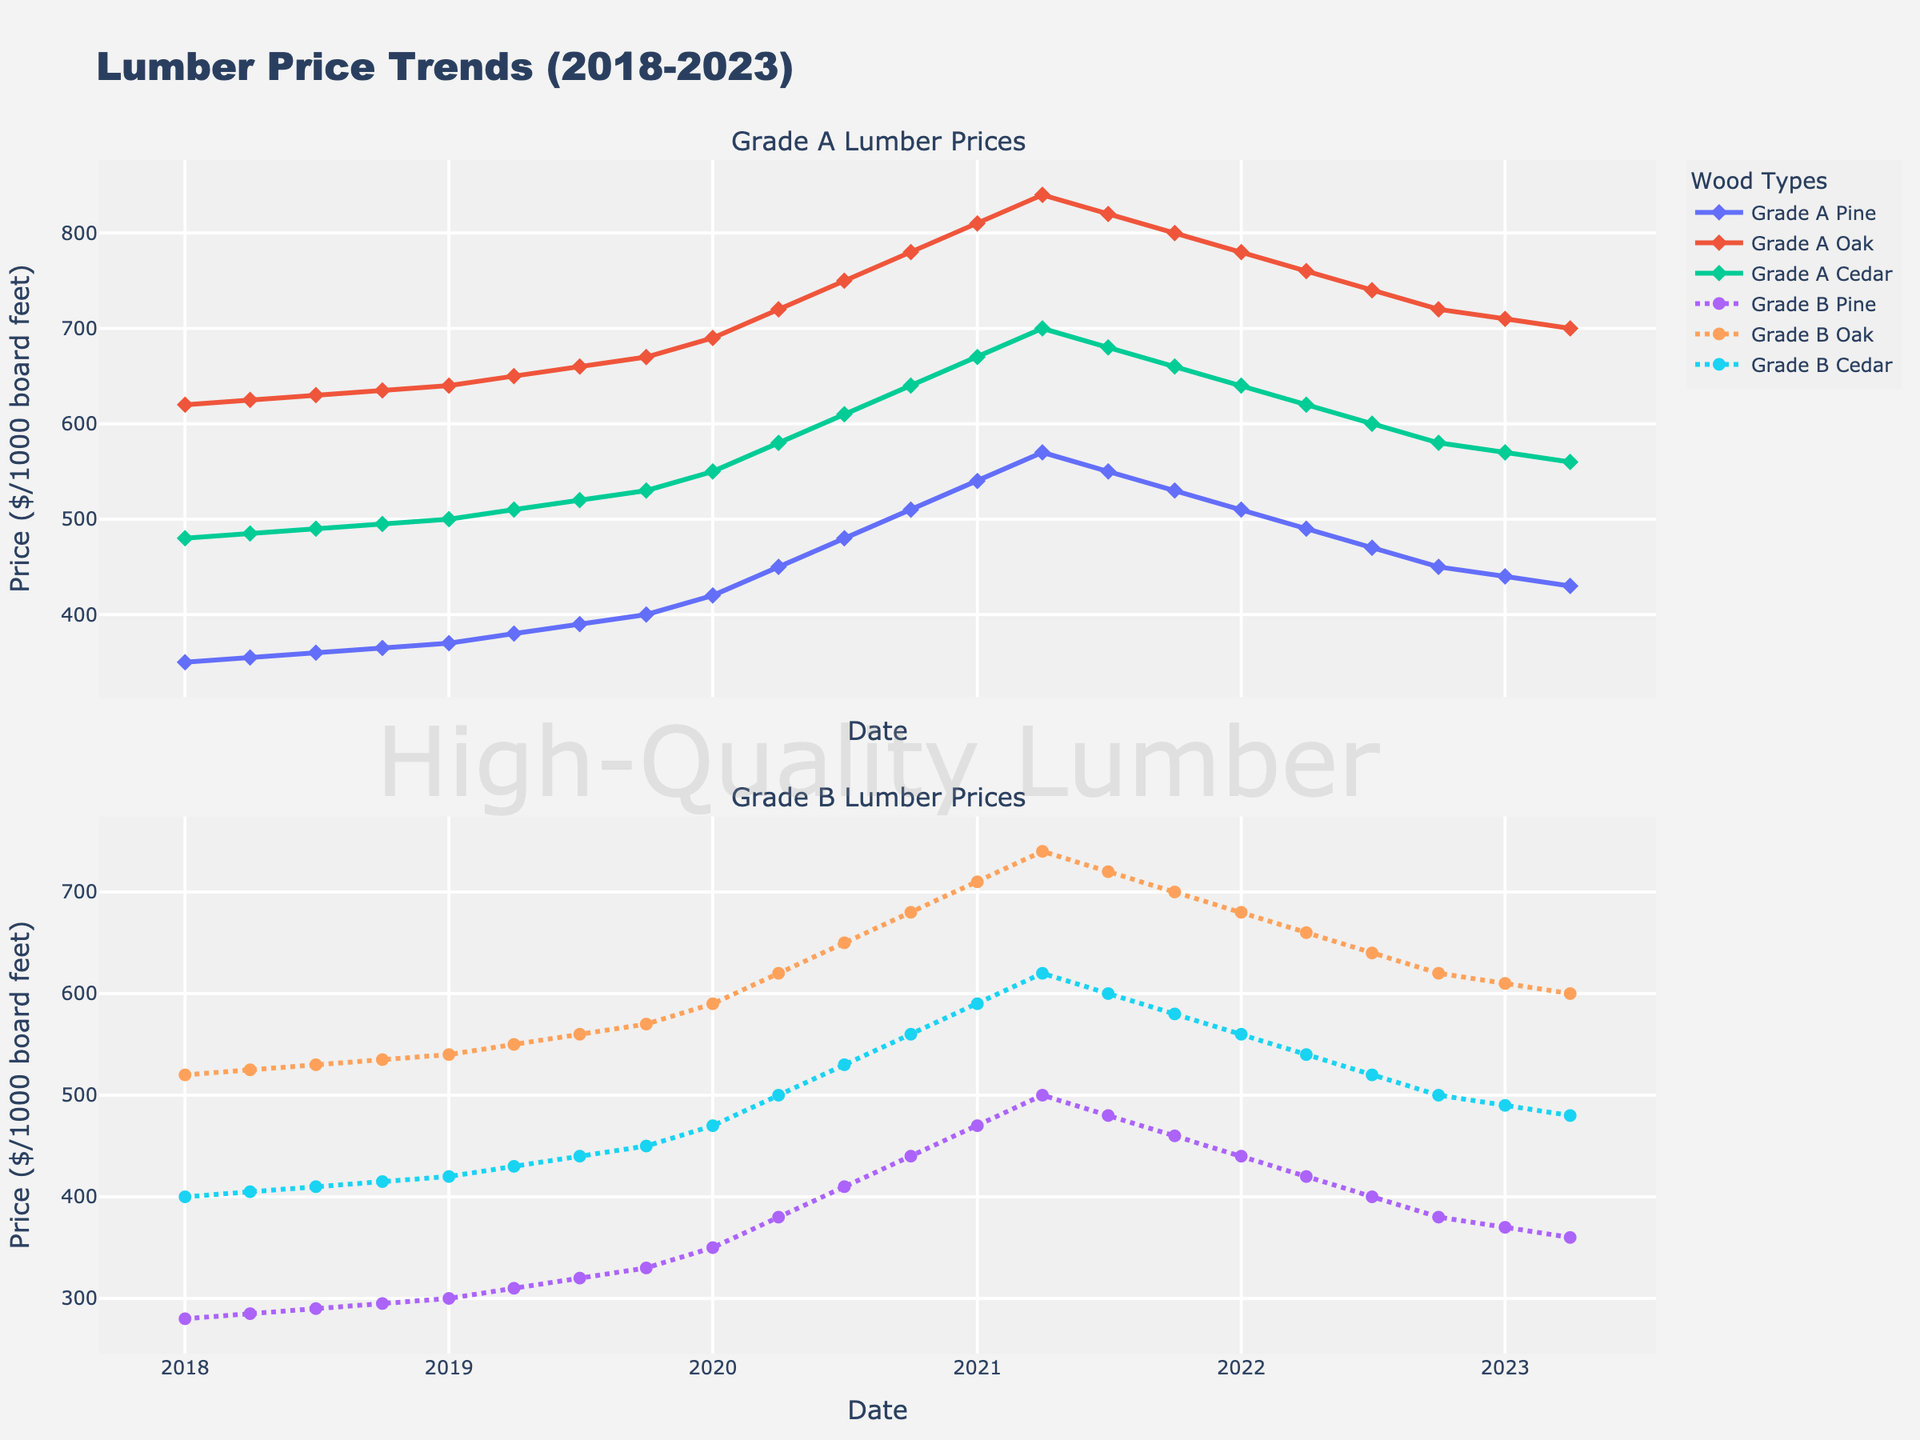Is the price of Grade A Pine in 2020 higher or lower than the price in 2018? To determine this, look at the line for Grade A Pine in the subplot for Grade A lumber prices. The point at 2020 shows a price of $420 in the first quarter, while the point at 2018 shows a price of $350 in the first quarter.
Answer: Higher Which type of Grade B lumber had the highest peak price, and what was the value? By examining the highest points in the second subplot for Grade B prices, the peak price for Grade B Oak is observed at $740 during 2021.
Answer: Grade B Oak, $740 What is the average price difference between Grade A Cedar and Grade B Cedar over the entire period? First, sum the prices of Grade A Cedar and Grade B Cedar at each time point, then calculate the total difference for each period, and find the average. $(480 + 485 + 490 + 495 + 500 + 510 + 520 + 530 + 550 + 580 + 610 + 640 + 670 + 700 + 680 + 660 + 640 + 620 + 600 + 580 + 570 + 560) - (400 + 405 + 410 + 415 + 420 + 430 + 440 + 450 + 470 + 500 + 530 + 560 + 590 + 620 + 600 + 580 + 560 + 540 + 520 + 500 + 490 + 480) sums to $14690 - $11630 which equals $3060 divided by 22 gives approximately $139.09.
Answer: $139.09 Which grade of lumber experienced the most significant price drop between 2021 and 2023? To determine this, compare the prices from the first quarter of 2021 to those of the first quarter of 2023 for all grades. The price for Grade A Pine dropped from $540 to $440, Grade B Pine from $470 to $370, Grade A Oak from $810 to $710, Grade B Oak from $710 to $610, Grade A Cedar from $670 to $570, and Grade B Cedar from $590 to $490. Grade B Pine shows the most significant drop of $100.
Answer: Grade B Pine During which year did all grades of lumber exhibit a consistent upward trend? Observe the plot for any year where the lines representing all grades are consistently increasing. In 2020, from the start to the end of the year, all price lines for Grade A and Grade B lumber are consistently trending upwards.
Answer: 2020 What is the price difference between Grade A Oak and Grade B Pine at the start of 2021? Look at the data points for January 2021. The price for Grade A Oak is $810 and for Grade B Pine is $470. The difference is $810 - $470 = $340.
Answer: $340 What color represents Grade A Cedar in the plot, and how can you identify it? In the Grade A subplot, the line representing Grade A Cedar can be identified by labeling or by observing the color coding provided in the legend. The color for Grade A Cedar is distinguished by a line with markers shaped differently from other grades.
Answer: Identifiable by legend Which Grade A lumber saw the highest price increase from the beginning to the middle of 2020? Look at the first and second-quarter values of 2020. Grade A Pine went from $420 to $450, a $30 increase. Grade A Oak from $690 to $720, also a $30 increase, and Grade A Cedar from $550 to $580, also a $30 increase. All Grade A lumber types had an equal increase of $30.
Answer: All equally increased Compare the trends for Grade A and Grade B Pine between 2019 and 2020. Which one increased at a faster rate? Observe the slope of the lines for both Grade A and Grade B Pine from the start of 2019 to the end of 2020. Grade A Pine goes from $370 to $510, an increase of $140, while Grade B Pine goes from $300 to $440, an increase of $140. Both grades increased at the same rate.
Answer: Both increased equally What was the relative position of Grade B Oak price in comparison to Grade A Cedar at the end of 2022? From the fourth quarter of 2022, compare the prices in the two subplots. Grade B Oak is priced at $620, while Grade A Cedar is priced at $580. Therefore, Grade B Oak is relatively higher.
Answer: Grade B Oak higher 